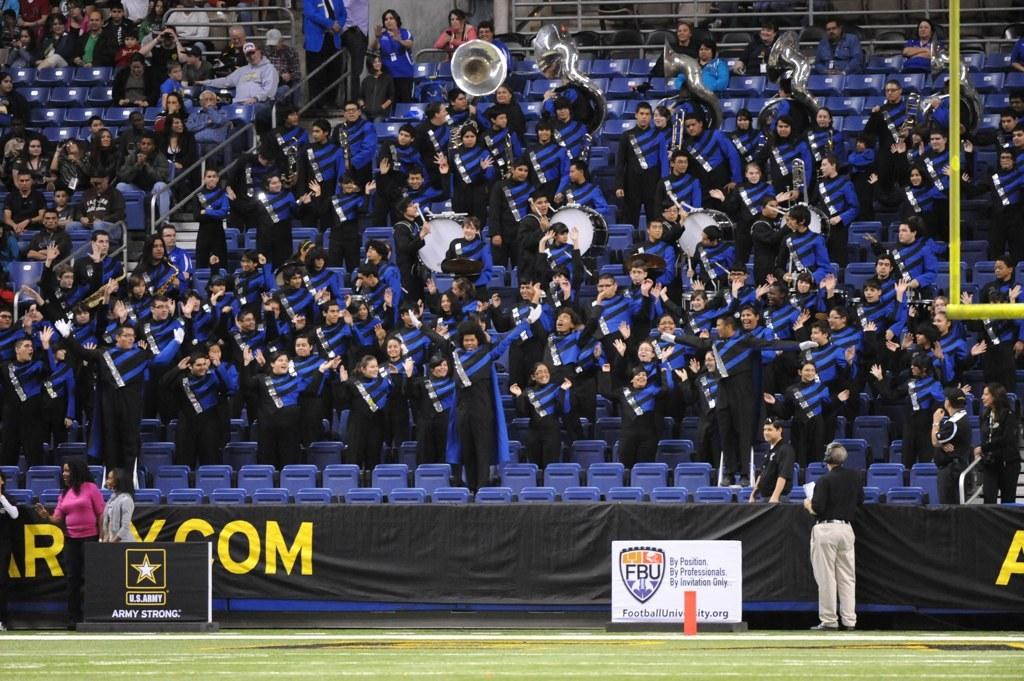Who or what can be seen in the image? There are people in the image. What objects are present in the image that are related to music? There are drums in the image. What type of furniture is visible in the image? There are chairs in the image. What type of material is present in the image? There is cloth in the image. What type of decorative items can be seen in the image? There are banners in the image. Can you see a pipe being played by one of the people in the image? There is no pipe present in the image; only drums are mentioned. Is there a harbor visible in the background of the image? There is no mention of a harbor in the provided facts, and therefore it cannot be determined if one is present in the image. 